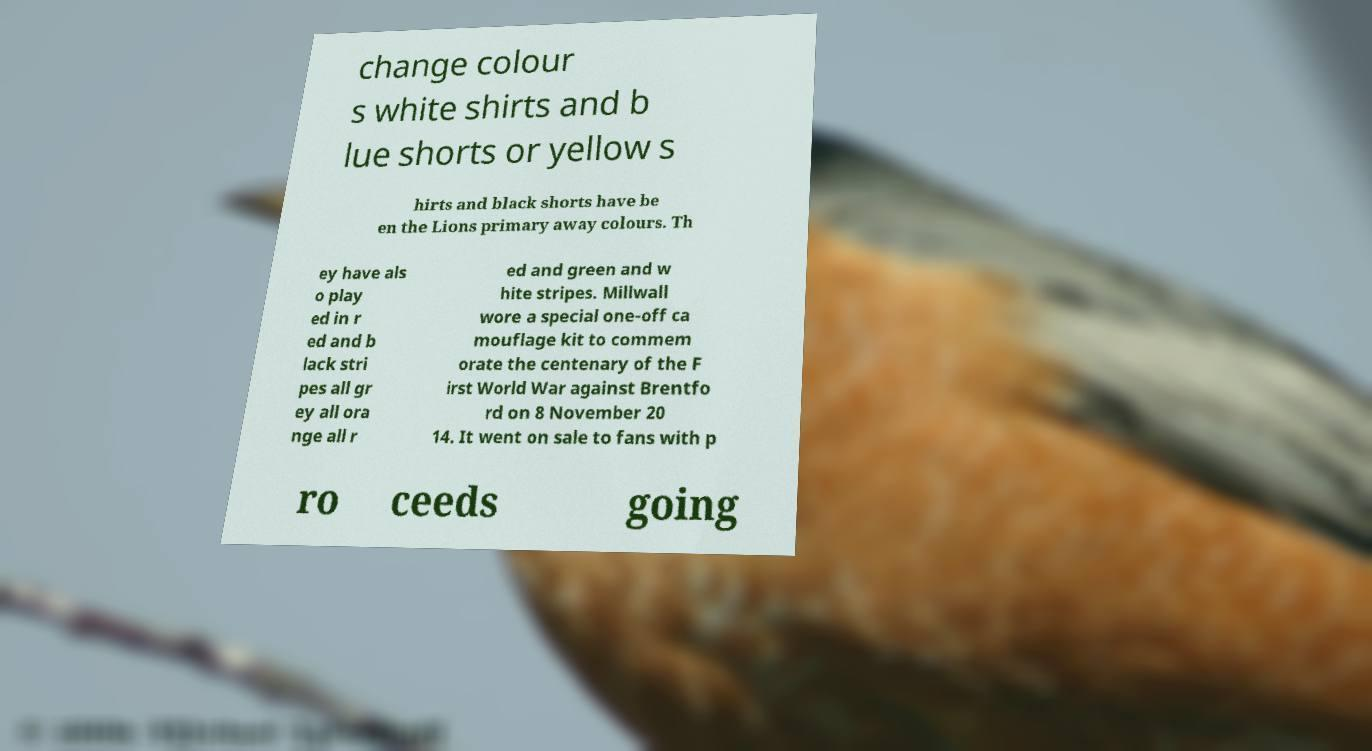There's text embedded in this image that I need extracted. Can you transcribe it verbatim? change colour s white shirts and b lue shorts or yellow s hirts and black shorts have be en the Lions primary away colours. Th ey have als o play ed in r ed and b lack stri pes all gr ey all ora nge all r ed and green and w hite stripes. Millwall wore a special one-off ca mouflage kit to commem orate the centenary of the F irst World War against Brentfo rd on 8 November 20 14. It went on sale to fans with p ro ceeds going 